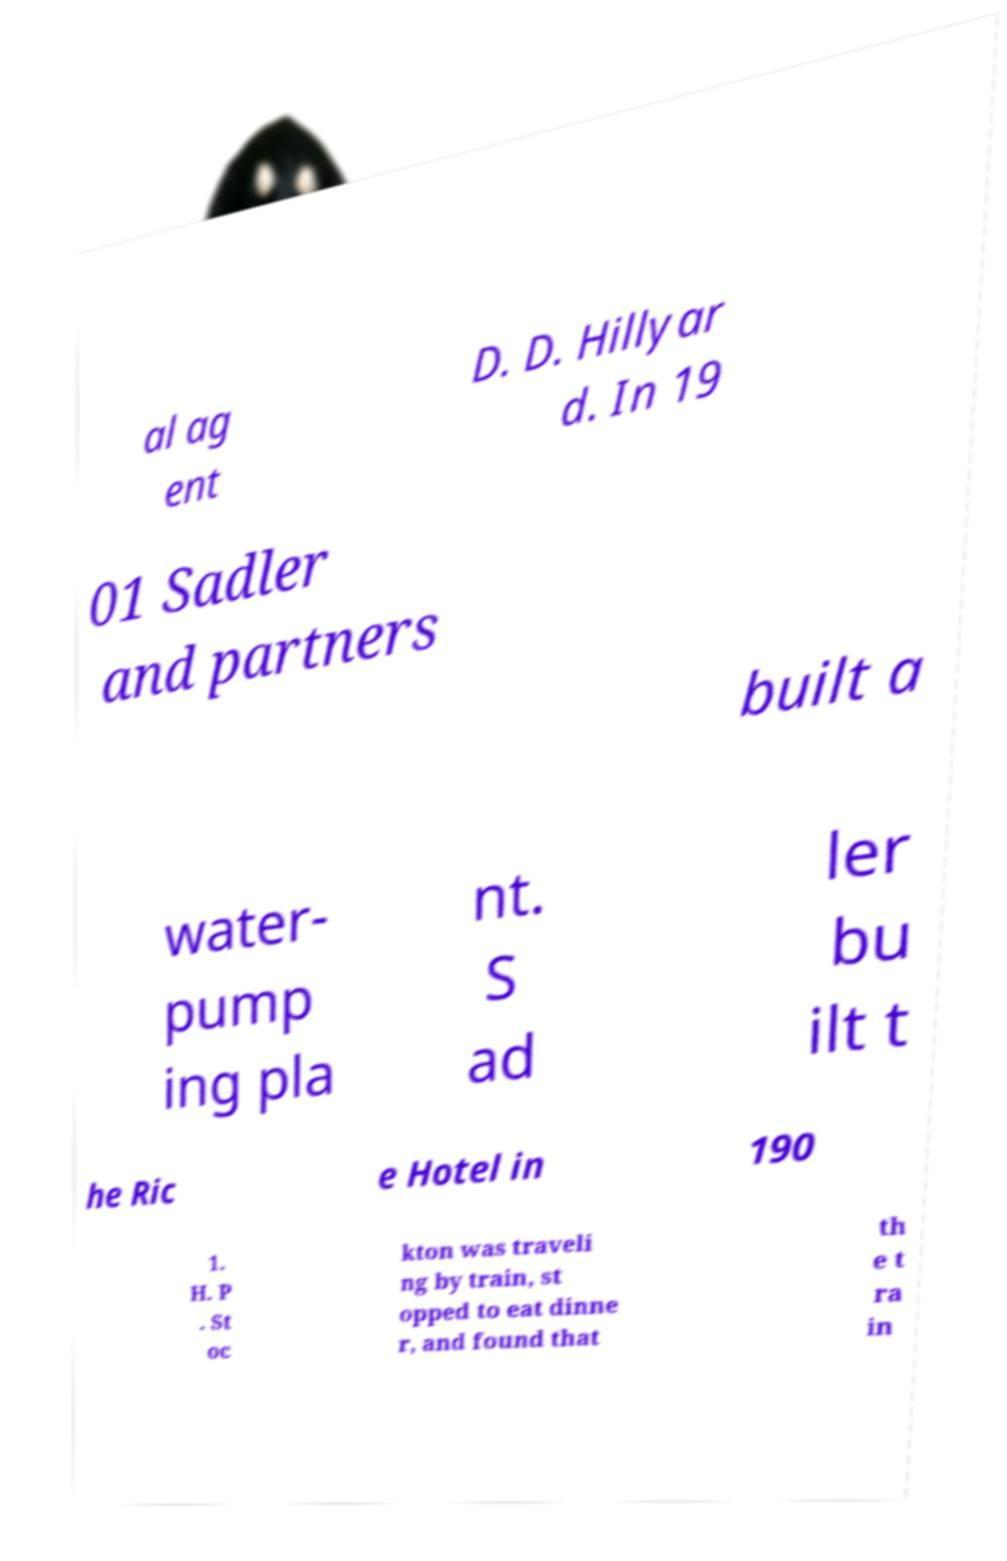Can you accurately transcribe the text from the provided image for me? al ag ent D. D. Hillyar d. In 19 01 Sadler and partners built a water- pump ing pla nt. S ad ler bu ilt t he Ric e Hotel in 190 1. H. P . St oc kton was traveli ng by train, st opped to eat dinne r, and found that th e t ra in 